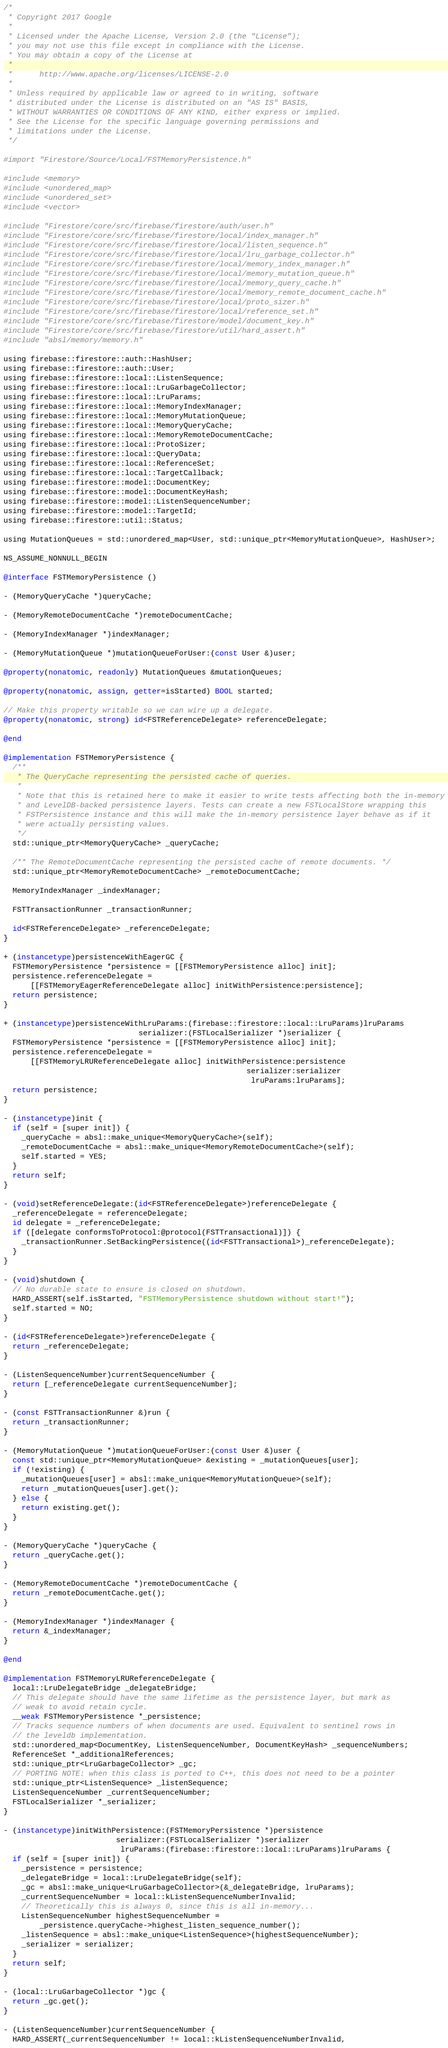Convert code to text. <code><loc_0><loc_0><loc_500><loc_500><_ObjectiveC_>/*
 * Copyright 2017 Google
 *
 * Licensed under the Apache License, Version 2.0 (the "License");
 * you may not use this file except in compliance with the License.
 * You may obtain a copy of the License at
 *
 *      http://www.apache.org/licenses/LICENSE-2.0
 *
 * Unless required by applicable law or agreed to in writing, software
 * distributed under the License is distributed on an "AS IS" BASIS,
 * WITHOUT WARRANTIES OR CONDITIONS OF ANY KIND, either express or implied.
 * See the License for the specific language governing permissions and
 * limitations under the License.
 */

#import "Firestore/Source/Local/FSTMemoryPersistence.h"

#include <memory>
#include <unordered_map>
#include <unordered_set>
#include <vector>

#include "Firestore/core/src/firebase/firestore/auth/user.h"
#include "Firestore/core/src/firebase/firestore/local/index_manager.h"
#include "Firestore/core/src/firebase/firestore/local/listen_sequence.h"
#include "Firestore/core/src/firebase/firestore/local/lru_garbage_collector.h"
#include "Firestore/core/src/firebase/firestore/local/memory_index_manager.h"
#include "Firestore/core/src/firebase/firestore/local/memory_mutation_queue.h"
#include "Firestore/core/src/firebase/firestore/local/memory_query_cache.h"
#include "Firestore/core/src/firebase/firestore/local/memory_remote_document_cache.h"
#include "Firestore/core/src/firebase/firestore/local/proto_sizer.h"
#include "Firestore/core/src/firebase/firestore/local/reference_set.h"
#include "Firestore/core/src/firebase/firestore/model/document_key.h"
#include "Firestore/core/src/firebase/firestore/util/hard_assert.h"
#include "absl/memory/memory.h"

using firebase::firestore::auth::HashUser;
using firebase::firestore::auth::User;
using firebase::firestore::local::ListenSequence;
using firebase::firestore::local::LruGarbageCollector;
using firebase::firestore::local::LruParams;
using firebase::firestore::local::MemoryIndexManager;
using firebase::firestore::local::MemoryMutationQueue;
using firebase::firestore::local::MemoryQueryCache;
using firebase::firestore::local::MemoryRemoteDocumentCache;
using firebase::firestore::local::ProtoSizer;
using firebase::firestore::local::QueryData;
using firebase::firestore::local::ReferenceSet;
using firebase::firestore::local::TargetCallback;
using firebase::firestore::model::DocumentKey;
using firebase::firestore::model::DocumentKeyHash;
using firebase::firestore::model::ListenSequenceNumber;
using firebase::firestore::model::TargetId;
using firebase::firestore::util::Status;

using MutationQueues = std::unordered_map<User, std::unique_ptr<MemoryMutationQueue>, HashUser>;

NS_ASSUME_NONNULL_BEGIN

@interface FSTMemoryPersistence ()

- (MemoryQueryCache *)queryCache;

- (MemoryRemoteDocumentCache *)remoteDocumentCache;

- (MemoryIndexManager *)indexManager;

- (MemoryMutationQueue *)mutationQueueForUser:(const User &)user;

@property(nonatomic, readonly) MutationQueues &mutationQueues;

@property(nonatomic, assign, getter=isStarted) BOOL started;

// Make this property writable so we can wire up a delegate.
@property(nonatomic, strong) id<FSTReferenceDelegate> referenceDelegate;

@end

@implementation FSTMemoryPersistence {
  /**
   * The QueryCache representing the persisted cache of queries.
   *
   * Note that this is retained here to make it easier to write tests affecting both the in-memory
   * and LevelDB-backed persistence layers. Tests can create a new FSTLocalStore wrapping this
   * FSTPersistence instance and this will make the in-memory persistence layer behave as if it
   * were actually persisting values.
   */
  std::unique_ptr<MemoryQueryCache> _queryCache;

  /** The RemoteDocumentCache representing the persisted cache of remote documents. */
  std::unique_ptr<MemoryRemoteDocumentCache> _remoteDocumentCache;

  MemoryIndexManager _indexManager;

  FSTTransactionRunner _transactionRunner;

  id<FSTReferenceDelegate> _referenceDelegate;
}

+ (instancetype)persistenceWithEagerGC {
  FSTMemoryPersistence *persistence = [[FSTMemoryPersistence alloc] init];
  persistence.referenceDelegate =
      [[FSTMemoryEagerReferenceDelegate alloc] initWithPersistence:persistence];
  return persistence;
}

+ (instancetype)persistenceWithLruParams:(firebase::firestore::local::LruParams)lruParams
                              serializer:(FSTLocalSerializer *)serializer {
  FSTMemoryPersistence *persistence = [[FSTMemoryPersistence alloc] init];
  persistence.referenceDelegate =
      [[FSTMemoryLRUReferenceDelegate alloc] initWithPersistence:persistence
                                                      serializer:serializer
                                                       lruParams:lruParams];
  return persistence;
}

- (instancetype)init {
  if (self = [super init]) {
    _queryCache = absl::make_unique<MemoryQueryCache>(self);
    _remoteDocumentCache = absl::make_unique<MemoryRemoteDocumentCache>(self);
    self.started = YES;
  }
  return self;
}

- (void)setReferenceDelegate:(id<FSTReferenceDelegate>)referenceDelegate {
  _referenceDelegate = referenceDelegate;
  id delegate = _referenceDelegate;
  if ([delegate conformsToProtocol:@protocol(FSTTransactional)]) {
    _transactionRunner.SetBackingPersistence((id<FSTTransactional>)_referenceDelegate);
  }
}

- (void)shutdown {
  // No durable state to ensure is closed on shutdown.
  HARD_ASSERT(self.isStarted, "FSTMemoryPersistence shutdown without start!");
  self.started = NO;
}

- (id<FSTReferenceDelegate>)referenceDelegate {
  return _referenceDelegate;
}

- (ListenSequenceNumber)currentSequenceNumber {
  return [_referenceDelegate currentSequenceNumber];
}

- (const FSTTransactionRunner &)run {
  return _transactionRunner;
}

- (MemoryMutationQueue *)mutationQueueForUser:(const User &)user {
  const std::unique_ptr<MemoryMutationQueue> &existing = _mutationQueues[user];
  if (!existing) {
    _mutationQueues[user] = absl::make_unique<MemoryMutationQueue>(self);
    return _mutationQueues[user].get();
  } else {
    return existing.get();
  }
}

- (MemoryQueryCache *)queryCache {
  return _queryCache.get();
}

- (MemoryRemoteDocumentCache *)remoteDocumentCache {
  return _remoteDocumentCache.get();
}

- (MemoryIndexManager *)indexManager {
  return &_indexManager;
}

@end

@implementation FSTMemoryLRUReferenceDelegate {
  local::LruDelegateBridge _delegateBridge;
  // This delegate should have the same lifetime as the persistence layer, but mark as
  // weak to avoid retain cycle.
  __weak FSTMemoryPersistence *_persistence;
  // Tracks sequence numbers of when documents are used. Equivalent to sentinel rows in
  // the leveldb implementation.
  std::unordered_map<DocumentKey, ListenSequenceNumber, DocumentKeyHash> _sequenceNumbers;
  ReferenceSet *_additionalReferences;
  std::unique_ptr<LruGarbageCollector> _gc;
  // PORTING NOTE: when this class is ported to C++, this does not need to be a pointer
  std::unique_ptr<ListenSequence> _listenSequence;
  ListenSequenceNumber _currentSequenceNumber;
  FSTLocalSerializer *_serializer;
}

- (instancetype)initWithPersistence:(FSTMemoryPersistence *)persistence
                         serializer:(FSTLocalSerializer *)serializer
                          lruParams:(firebase::firestore::local::LruParams)lruParams {
  if (self = [super init]) {
    _persistence = persistence;
    _delegateBridge = local::LruDelegateBridge(self);
    _gc = absl::make_unique<LruGarbageCollector>(&_delegateBridge, lruParams);
    _currentSequenceNumber = local::kListenSequenceNumberInvalid;
    // Theoretically this is always 0, since this is all in-memory...
    ListenSequenceNumber highestSequenceNumber =
        _persistence.queryCache->highest_listen_sequence_number();
    _listenSequence = absl::make_unique<ListenSequence>(highestSequenceNumber);
    _serializer = serializer;
  }
  return self;
}

- (local::LruGarbageCollector *)gc {
  return _gc.get();
}

- (ListenSequenceNumber)currentSequenceNumber {
  HARD_ASSERT(_currentSequenceNumber != local::kListenSequenceNumberInvalid,</code> 